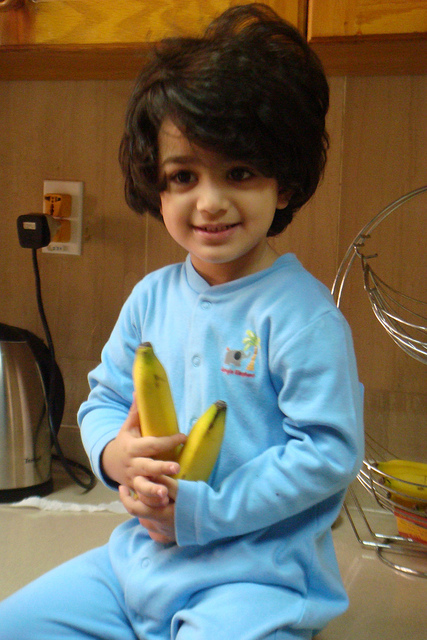Describe what's visible in the kitchen and its items. The kitchen features a wooden cupboard spanning the top part of the image. Below it, there’s a wall socket on the wooden paneling towards the left. On the counter, a child is happily holding two bananas in their right hand. Scattered around are four additional bananas: two are near each other at the center, and two on the far right, with a basket containing more bananas. A kettle is placed on the counter to the left, adding to the cozy and domestic atmosphere. What do you think the child is planning to do with the bananas? The child likely plans to eat the bananas or help prepare a snack with them. Given the relaxed domestic setting, they might be assisting with making breakfast or a healthy fruit snack. Their cheerful expression indicates they are enjoying their time in the kitchen. 